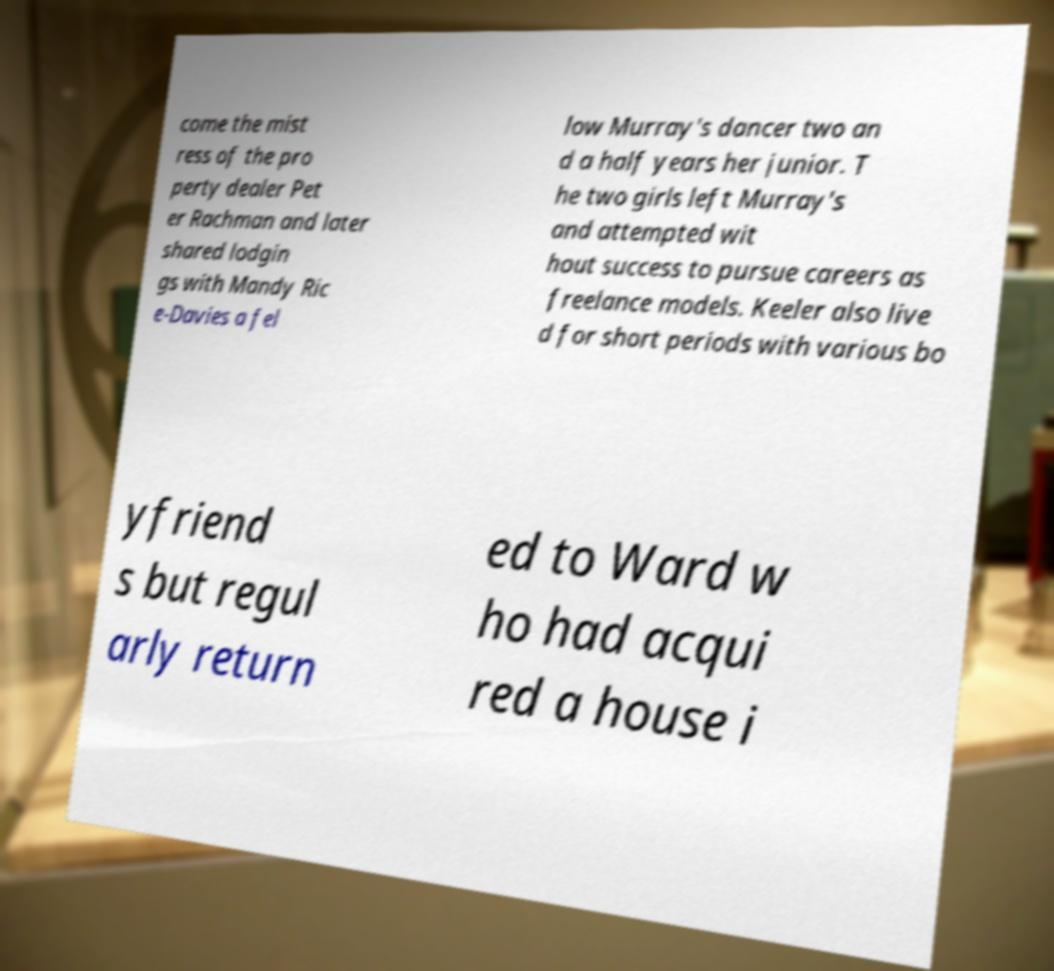Please read and relay the text visible in this image. What does it say? come the mist ress of the pro perty dealer Pet er Rachman and later shared lodgin gs with Mandy Ric e-Davies a fel low Murray's dancer two an d a half years her junior. T he two girls left Murray's and attempted wit hout success to pursue careers as freelance models. Keeler also live d for short periods with various bo yfriend s but regul arly return ed to Ward w ho had acqui red a house i 